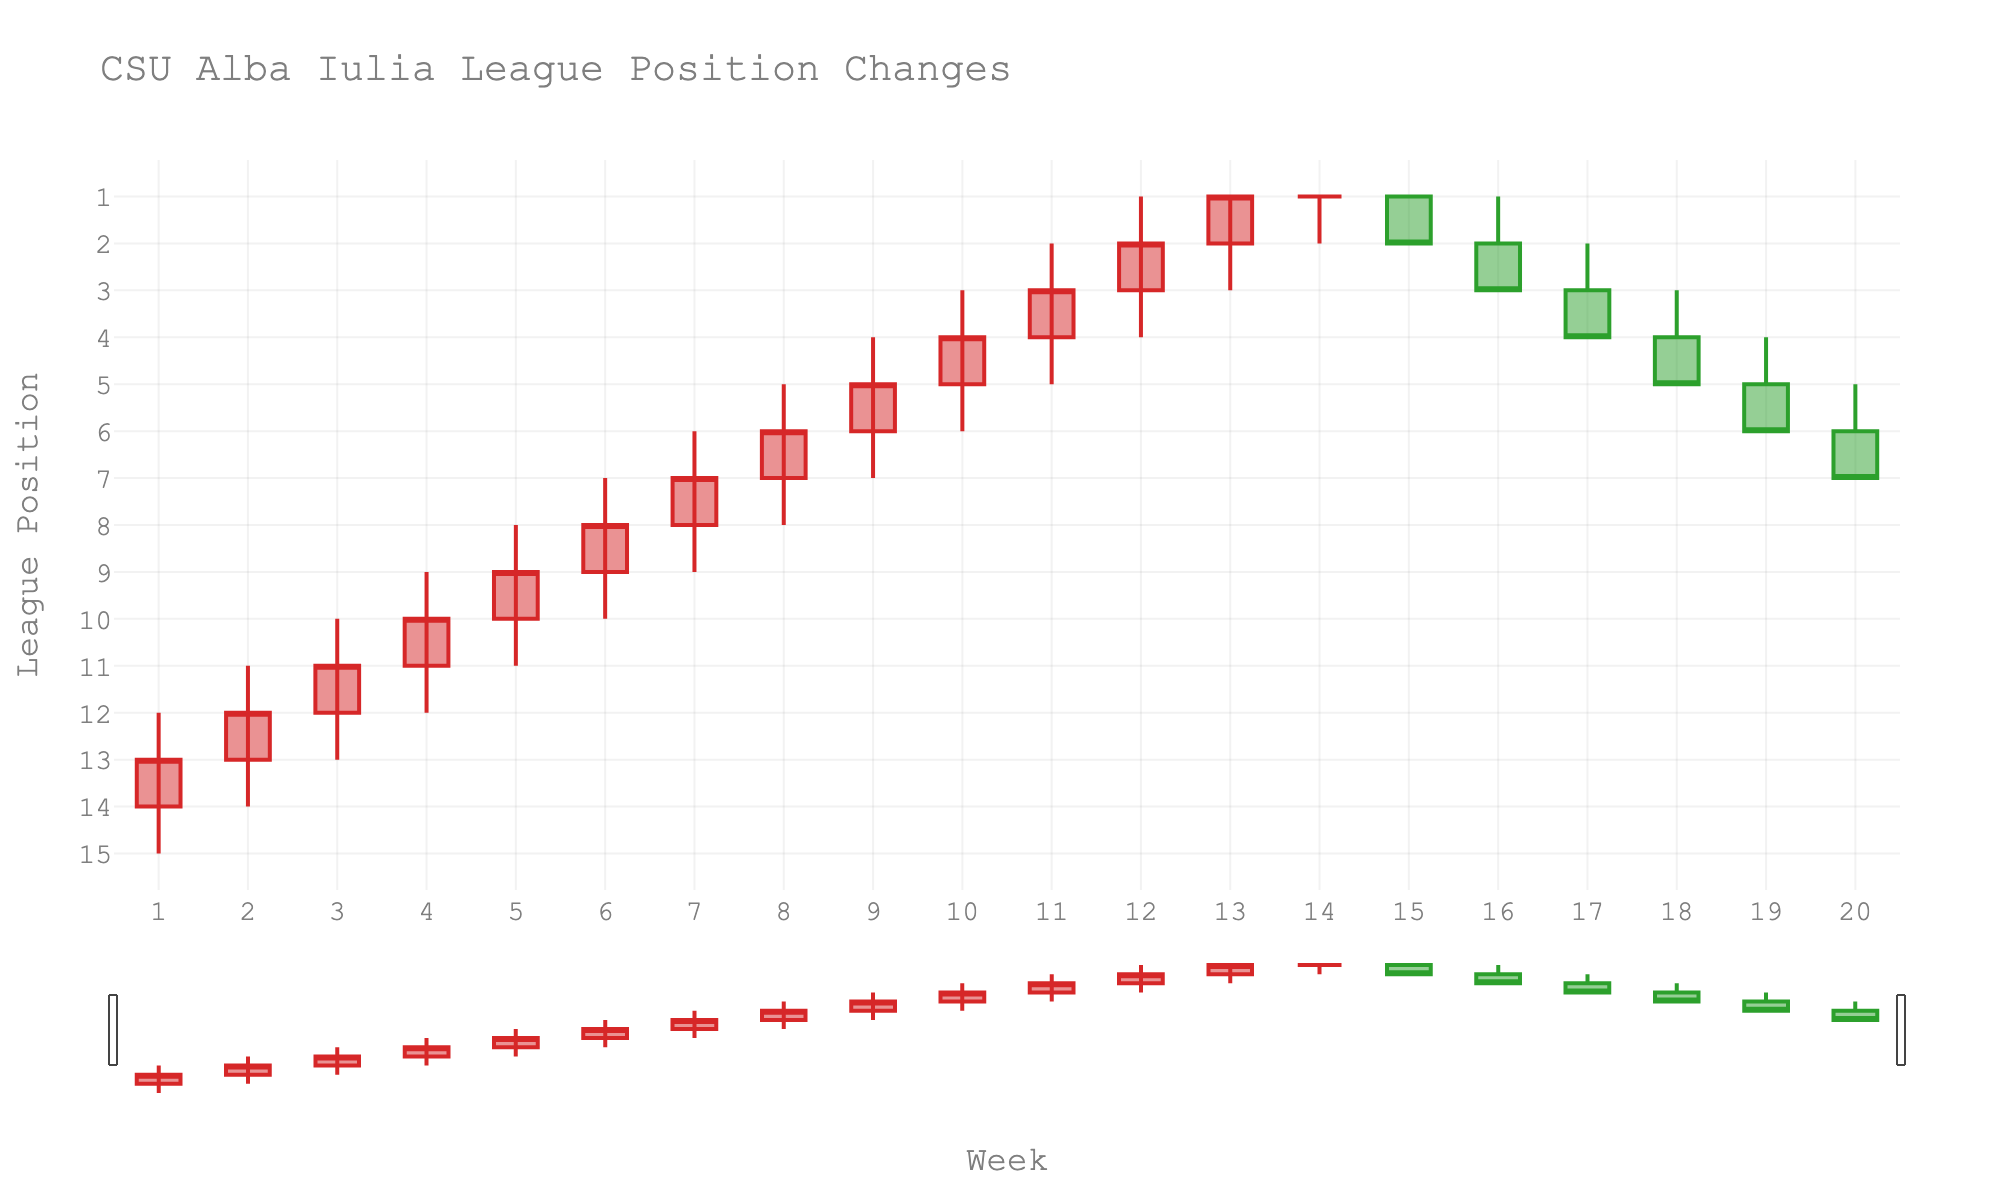What's the title of the figure? The title is located at the top of the figure and usually provides a summary of what the chart represents. In this case, it reads "CSU Alba Iulia League Position Changes".
Answer: CSU Alba Iulia League Position Changes What are the labels of the x-axis and y-axis? The labels for the x-axis and y-axis are placed along the respective axes to describe what the axes represent. Here, the x-axis is labeled "Week" and the y-axis is labeled "League Position".
Answer: Week and League Position In which week did CSU Alba Iulia achieve their best position, and what was that position? You can identify this by finding the week where the lowest position value is recorded since a lower number indicating a better position. The lowest position (value 1) occurs in Week 13.
Answer: Week 13 How many weeks did CSU Alba Iulia maintain the 1st position? To determine this, observe how many times the "close" value is at position 1. This occurs in Weeks 13, 14, and 15.
Answer: 3 weeks What was the highest position CSU Alba Iulia achieved in Week 10? The high value indicates the highest position achieved on a particular week. For Week 10, the highest position is 3.
Answer: Position 3 How long did it take for CSU Alba Iulia to reach a single-digit league position? To determine this, find the first week where both the high and low values fall within single digits. This happens in Week 6.
Answer: 6 weeks Which weeks did CSU Alba Iulia's league position start improving and then stabilize? Find the trend where the league position improves till it reaches the peak and then stabilizes. The position improves until Week 13 and stabilizes around the 1st position from Weeks 14 to 15.
Answer: Weeks 13 to 15 What was the most common range of positions held by CSU Alba Iulia in the first 10 weeks? Calculate by observing the "high" and "low" values across the first 10 weeks. Most weeks show a range between mid to late single digits and early teens. E.g., weeks 1-7 ranges from around 12 to 8, 7 to 3, etc.
Answer: 3-12 Did CSU Alba Iulia see any weeks with worsening position, followed by an improvement? If yes, identify an instance. Observe the trend lines for a week where position numbers increase (a worse ranking) then decrease (an improved ranking). Between Week 1-3, where we see the positions worsening, followed by slight stabilization and increase later.
Answer: Weeks 1-3, stabilization & improvement In which week was the largest week-to-week drop in position observed, and what were the values? Calculate by checking weeks where "low" values suddenly drop significantly from previous weeks. For instance, between Weeks 2 and 3 we see a low shifting from 14 to 13.
Answer: Drop seen between Weeks 16 and 17: from 1 to low of 2 